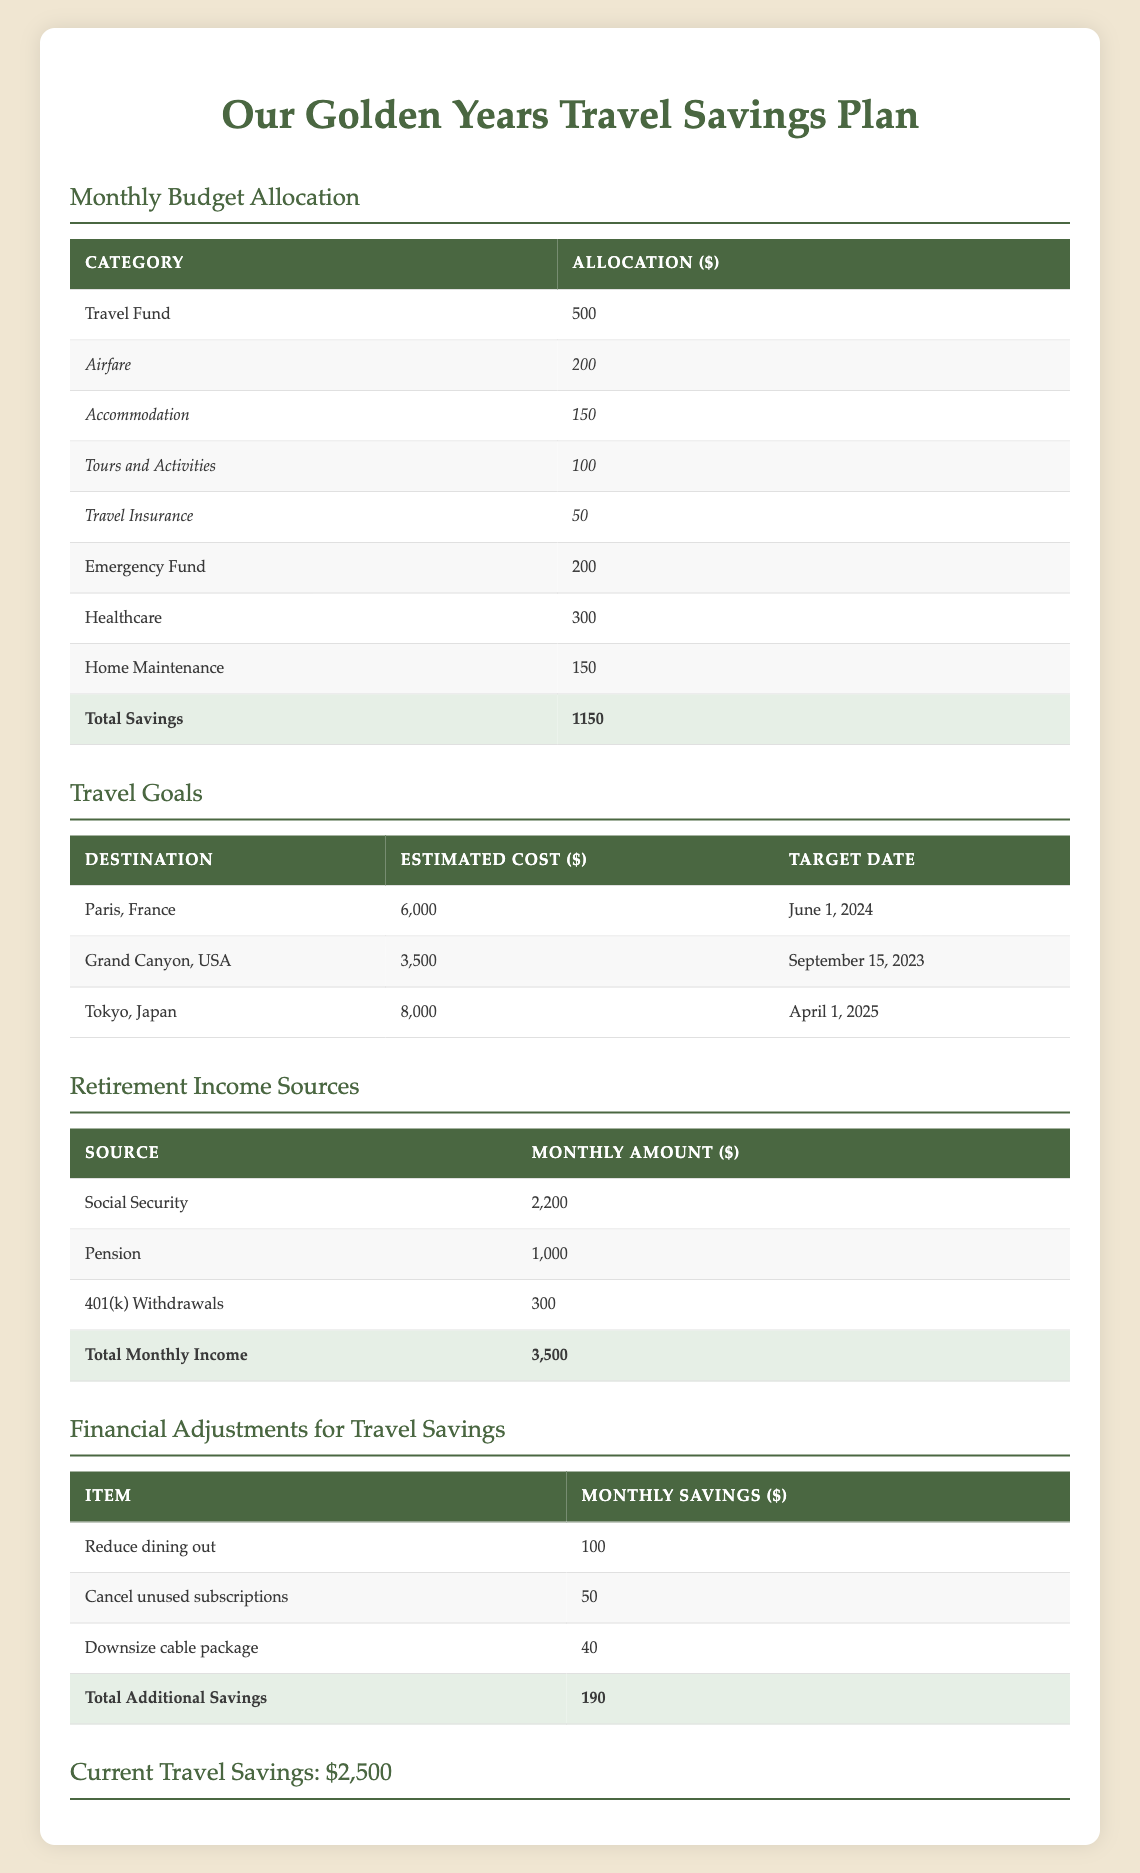What is the monthly allocation for the Travel Fund? The table directly lists the monthly allocation for the Travel Fund as $500.
Answer: 500 How much is currently saved for travel? The table states that the current travel savings amount is $2,500.
Answer: 2500 What is the total monthly income from retirement sources? The table shows the total monthly income from Social Security, Pension, and 401(k) Withdrawals adds up to $3,500.
Answer: 3500 Is the allocation for Healthcare greater than or equal to the allocation for Emergency Fund? The allocation for Healthcare is $300 and for Emergency Fund is $200. Since $300 is greater than $200, the statement is true.
Answer: Yes What percentage of monthly income is allocated to the Travel Fund? To find the percentage, divide the Travel Fund allocation ($500) by the total monthly income ($3,500) and multiply by 100: (500 / 3500) * 100 = 14.29%, approximately 14%.
Answer: 14.29% How much more is needed to reach the target savings for a trip to Paris? The estimated cost for the trip to Paris is $6,000. Subtracting the current travel savings of $2,500 gives $6,000 - $2,500 = $3,500 more needed.
Answer: 3500 What is the total amount allocated for Tours and Activities and Travel Insurance combined? The allocation for Tours and Activities is $100 and the allocation for Travel Insurance is $50. Adding these amounts, $100 + $50 = $150, gives the total combined allocation of $150.
Answer: 150 How much monthly savings can be achieved if the couple implements all suggested financial adjustments? The table lists total additional savings from financial adjustments as $190, which can be added to their current savings effort.
Answer: 190 Which travel destination has the highest estimated cost? From the travel goals, Tokyo, Japan has the highest estimated cost of $8,000, compared to Paris and Grand Canyon.
Answer: Tokyo, Japan 